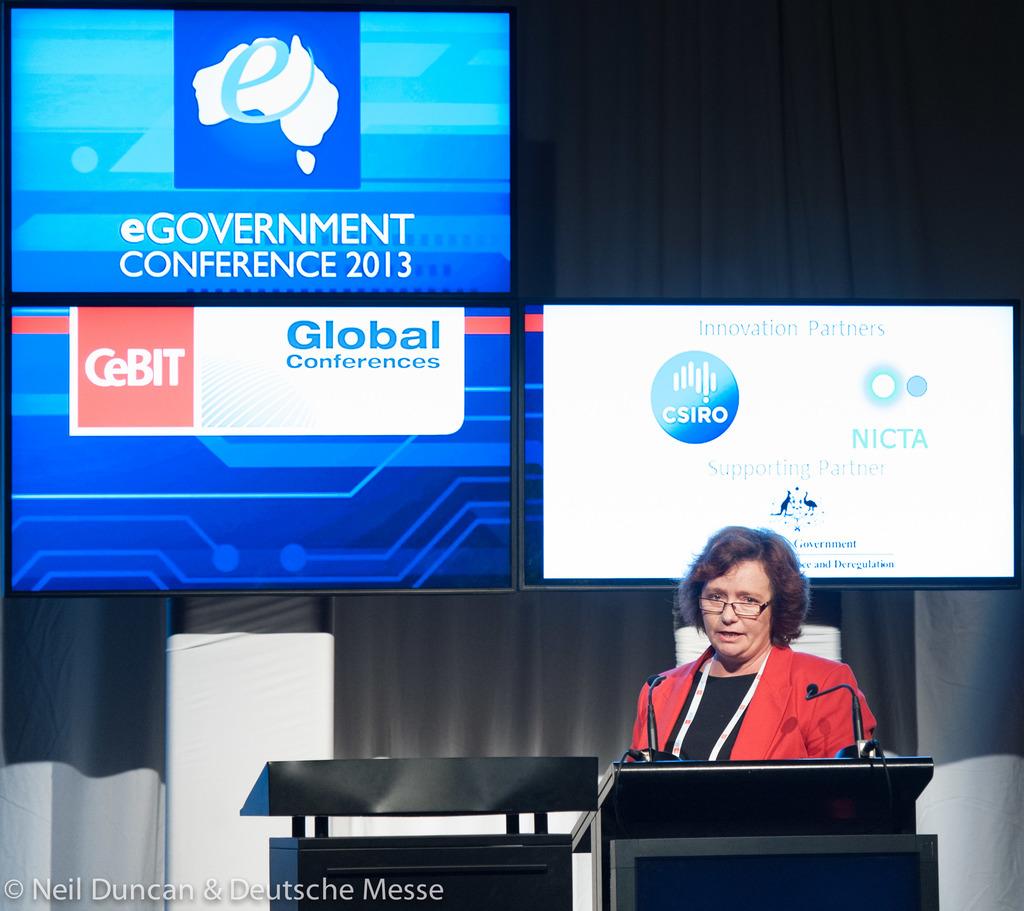What year was this conference held?
Offer a terse response. 2013. What conference is this?
Your answer should be compact. Egovernment. 